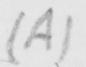Please provide the text content of this handwritten line. ( A ) 